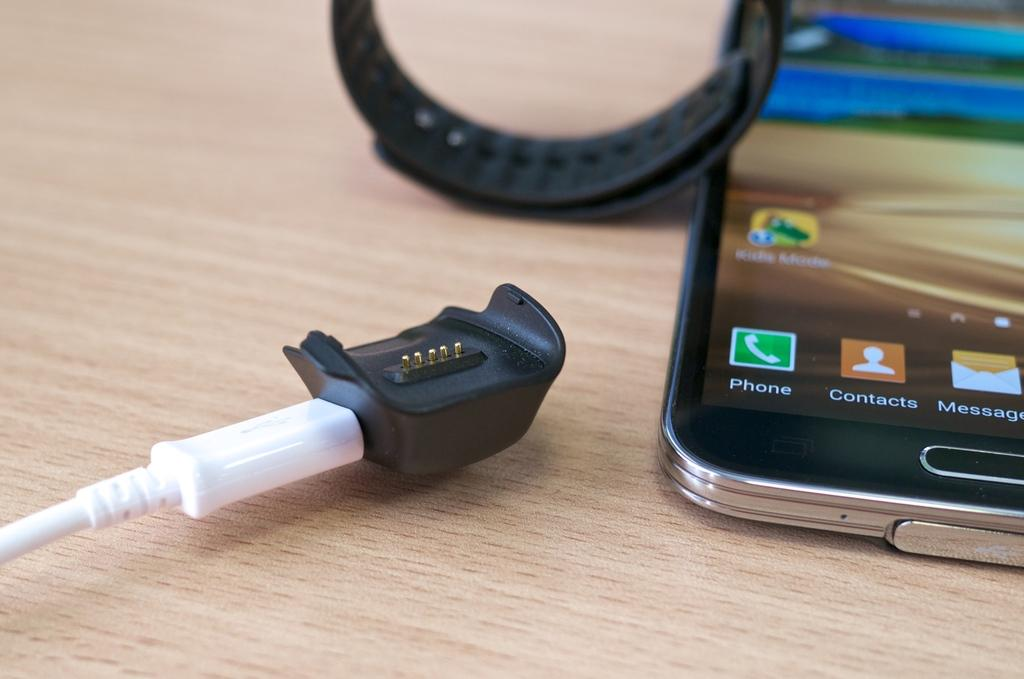What type of object is hanging in the image? There is a mobile in the image. What time-telling device is visible in the image? There is a watch in the image. What type of wire is present in the image? There is a cable in the image. What material is the table made of in the image? The table in the image is made of wood. Can you see the coastline in the image? There is no coastline visible in the image. What type of heart is present in the image? There is no heart present in the image. 